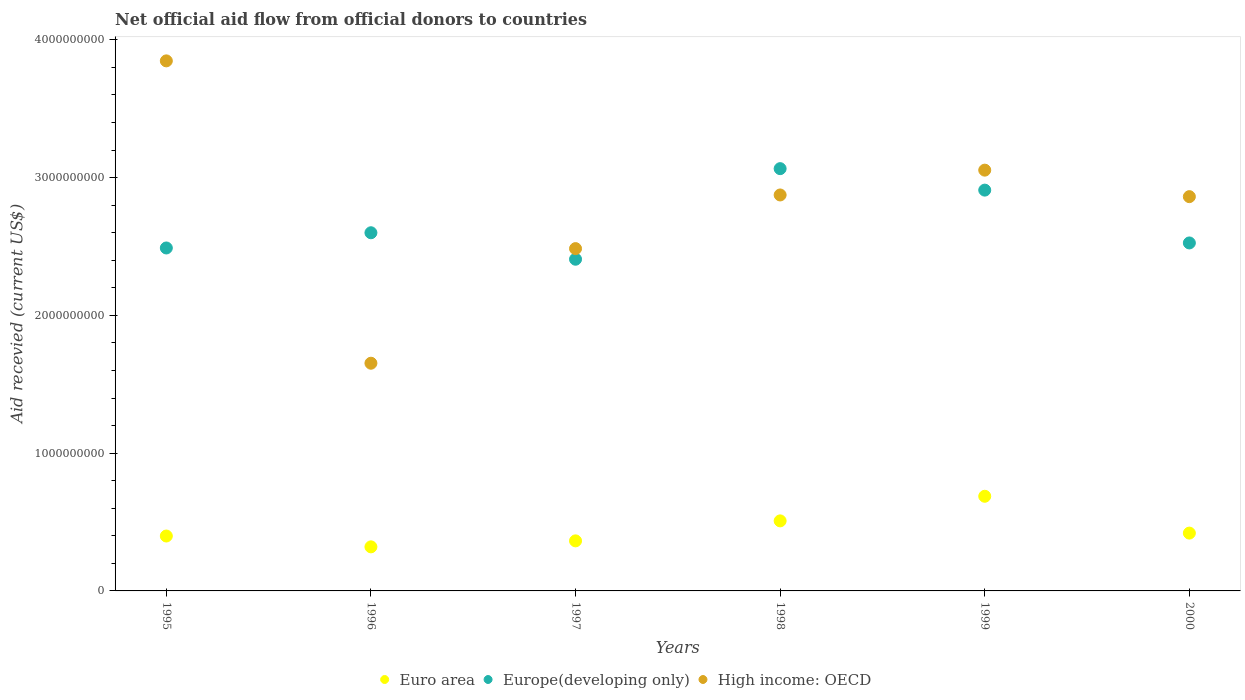How many different coloured dotlines are there?
Your answer should be compact. 3. Is the number of dotlines equal to the number of legend labels?
Ensure brevity in your answer.  Yes. What is the total aid received in Europe(developing only) in 1997?
Give a very brief answer. 2.41e+09. Across all years, what is the maximum total aid received in Euro area?
Provide a succinct answer. 6.87e+08. Across all years, what is the minimum total aid received in Euro area?
Make the answer very short. 3.20e+08. What is the total total aid received in High income: OECD in the graph?
Your answer should be compact. 1.68e+1. What is the difference between the total aid received in Europe(developing only) in 1995 and that in 1997?
Your answer should be compact. 8.17e+07. What is the difference between the total aid received in Euro area in 1995 and the total aid received in Europe(developing only) in 1999?
Provide a short and direct response. -2.51e+09. What is the average total aid received in Europe(developing only) per year?
Offer a terse response. 2.67e+09. In the year 1998, what is the difference between the total aid received in Europe(developing only) and total aid received in Euro area?
Provide a succinct answer. 2.56e+09. In how many years, is the total aid received in Euro area greater than 1800000000 US$?
Offer a very short reply. 0. What is the ratio of the total aid received in Euro area in 1995 to that in 2000?
Make the answer very short. 0.95. What is the difference between the highest and the second highest total aid received in Europe(developing only)?
Make the answer very short. 1.56e+08. What is the difference between the highest and the lowest total aid received in Europe(developing only)?
Your answer should be very brief. 6.57e+08. In how many years, is the total aid received in Europe(developing only) greater than the average total aid received in Europe(developing only) taken over all years?
Offer a terse response. 2. Is the sum of the total aid received in Euro area in 1995 and 1996 greater than the maximum total aid received in High income: OECD across all years?
Your answer should be compact. No. Is it the case that in every year, the sum of the total aid received in Europe(developing only) and total aid received in Euro area  is greater than the total aid received in High income: OECD?
Your answer should be very brief. No. Does the total aid received in Euro area monotonically increase over the years?
Keep it short and to the point. No. Are the values on the major ticks of Y-axis written in scientific E-notation?
Make the answer very short. No. How are the legend labels stacked?
Your answer should be very brief. Horizontal. What is the title of the graph?
Offer a very short reply. Net official aid flow from official donors to countries. What is the label or title of the X-axis?
Provide a short and direct response. Years. What is the label or title of the Y-axis?
Make the answer very short. Aid recevied (current US$). What is the Aid recevied (current US$) in Euro area in 1995?
Your answer should be compact. 3.98e+08. What is the Aid recevied (current US$) of Europe(developing only) in 1995?
Provide a succinct answer. 2.49e+09. What is the Aid recevied (current US$) in High income: OECD in 1995?
Your answer should be compact. 3.85e+09. What is the Aid recevied (current US$) in Euro area in 1996?
Give a very brief answer. 3.20e+08. What is the Aid recevied (current US$) of Europe(developing only) in 1996?
Your answer should be compact. 2.60e+09. What is the Aid recevied (current US$) of High income: OECD in 1996?
Ensure brevity in your answer.  1.65e+09. What is the Aid recevied (current US$) of Euro area in 1997?
Offer a very short reply. 3.63e+08. What is the Aid recevied (current US$) of Europe(developing only) in 1997?
Make the answer very short. 2.41e+09. What is the Aid recevied (current US$) of High income: OECD in 1997?
Provide a short and direct response. 2.48e+09. What is the Aid recevied (current US$) of Euro area in 1998?
Keep it short and to the point. 5.08e+08. What is the Aid recevied (current US$) in Europe(developing only) in 1998?
Offer a terse response. 3.06e+09. What is the Aid recevied (current US$) in High income: OECD in 1998?
Your response must be concise. 2.87e+09. What is the Aid recevied (current US$) in Euro area in 1999?
Ensure brevity in your answer.  6.87e+08. What is the Aid recevied (current US$) in Europe(developing only) in 1999?
Make the answer very short. 2.91e+09. What is the Aid recevied (current US$) in High income: OECD in 1999?
Provide a short and direct response. 3.05e+09. What is the Aid recevied (current US$) of Euro area in 2000?
Keep it short and to the point. 4.20e+08. What is the Aid recevied (current US$) in Europe(developing only) in 2000?
Offer a terse response. 2.53e+09. What is the Aid recevied (current US$) in High income: OECD in 2000?
Ensure brevity in your answer.  2.86e+09. Across all years, what is the maximum Aid recevied (current US$) of Euro area?
Offer a very short reply. 6.87e+08. Across all years, what is the maximum Aid recevied (current US$) in Europe(developing only)?
Provide a succinct answer. 3.06e+09. Across all years, what is the maximum Aid recevied (current US$) in High income: OECD?
Your answer should be compact. 3.85e+09. Across all years, what is the minimum Aid recevied (current US$) of Euro area?
Ensure brevity in your answer.  3.20e+08. Across all years, what is the minimum Aid recevied (current US$) of Europe(developing only)?
Your answer should be compact. 2.41e+09. Across all years, what is the minimum Aid recevied (current US$) in High income: OECD?
Make the answer very short. 1.65e+09. What is the total Aid recevied (current US$) of Euro area in the graph?
Offer a very short reply. 2.70e+09. What is the total Aid recevied (current US$) in Europe(developing only) in the graph?
Give a very brief answer. 1.60e+1. What is the total Aid recevied (current US$) in High income: OECD in the graph?
Provide a short and direct response. 1.68e+1. What is the difference between the Aid recevied (current US$) in Euro area in 1995 and that in 1996?
Your response must be concise. 7.86e+07. What is the difference between the Aid recevied (current US$) in Europe(developing only) in 1995 and that in 1996?
Provide a succinct answer. -1.10e+08. What is the difference between the Aid recevied (current US$) in High income: OECD in 1995 and that in 1996?
Make the answer very short. 2.19e+09. What is the difference between the Aid recevied (current US$) of Euro area in 1995 and that in 1997?
Ensure brevity in your answer.  3.52e+07. What is the difference between the Aid recevied (current US$) in Europe(developing only) in 1995 and that in 1997?
Provide a short and direct response. 8.17e+07. What is the difference between the Aid recevied (current US$) of High income: OECD in 1995 and that in 1997?
Keep it short and to the point. 1.36e+09. What is the difference between the Aid recevied (current US$) of Euro area in 1995 and that in 1998?
Ensure brevity in your answer.  -1.10e+08. What is the difference between the Aid recevied (current US$) in Europe(developing only) in 1995 and that in 1998?
Your answer should be very brief. -5.76e+08. What is the difference between the Aid recevied (current US$) of High income: OECD in 1995 and that in 1998?
Ensure brevity in your answer.  9.73e+08. What is the difference between the Aid recevied (current US$) of Euro area in 1995 and that in 1999?
Ensure brevity in your answer.  -2.88e+08. What is the difference between the Aid recevied (current US$) in Europe(developing only) in 1995 and that in 1999?
Give a very brief answer. -4.20e+08. What is the difference between the Aid recevied (current US$) in High income: OECD in 1995 and that in 1999?
Your response must be concise. 7.93e+08. What is the difference between the Aid recevied (current US$) in Euro area in 1995 and that in 2000?
Give a very brief answer. -2.11e+07. What is the difference between the Aid recevied (current US$) of Europe(developing only) in 1995 and that in 2000?
Your answer should be compact. -3.65e+07. What is the difference between the Aid recevied (current US$) of High income: OECD in 1995 and that in 2000?
Your response must be concise. 9.85e+08. What is the difference between the Aid recevied (current US$) of Euro area in 1996 and that in 1997?
Offer a very short reply. -4.35e+07. What is the difference between the Aid recevied (current US$) in Europe(developing only) in 1996 and that in 1997?
Your answer should be compact. 1.92e+08. What is the difference between the Aid recevied (current US$) of High income: OECD in 1996 and that in 1997?
Your response must be concise. -8.32e+08. What is the difference between the Aid recevied (current US$) in Euro area in 1996 and that in 1998?
Your answer should be compact. -1.88e+08. What is the difference between the Aid recevied (current US$) in Europe(developing only) in 1996 and that in 1998?
Make the answer very short. -4.65e+08. What is the difference between the Aid recevied (current US$) in High income: OECD in 1996 and that in 1998?
Your answer should be compact. -1.22e+09. What is the difference between the Aid recevied (current US$) of Euro area in 1996 and that in 1999?
Offer a terse response. -3.67e+08. What is the difference between the Aid recevied (current US$) in Europe(developing only) in 1996 and that in 1999?
Make the answer very short. -3.09e+08. What is the difference between the Aid recevied (current US$) in High income: OECD in 1996 and that in 1999?
Provide a succinct answer. -1.40e+09. What is the difference between the Aid recevied (current US$) in Euro area in 1996 and that in 2000?
Ensure brevity in your answer.  -9.98e+07. What is the difference between the Aid recevied (current US$) of Europe(developing only) in 1996 and that in 2000?
Make the answer very short. 7.39e+07. What is the difference between the Aid recevied (current US$) of High income: OECD in 1996 and that in 2000?
Ensure brevity in your answer.  -1.21e+09. What is the difference between the Aid recevied (current US$) in Euro area in 1997 and that in 1998?
Ensure brevity in your answer.  -1.45e+08. What is the difference between the Aid recevied (current US$) of Europe(developing only) in 1997 and that in 1998?
Make the answer very short. -6.57e+08. What is the difference between the Aid recevied (current US$) of High income: OECD in 1997 and that in 1998?
Provide a short and direct response. -3.89e+08. What is the difference between the Aid recevied (current US$) in Euro area in 1997 and that in 1999?
Ensure brevity in your answer.  -3.24e+08. What is the difference between the Aid recevied (current US$) of Europe(developing only) in 1997 and that in 1999?
Your answer should be compact. -5.02e+08. What is the difference between the Aid recevied (current US$) of High income: OECD in 1997 and that in 1999?
Provide a succinct answer. -5.70e+08. What is the difference between the Aid recevied (current US$) in Euro area in 1997 and that in 2000?
Your answer should be compact. -5.63e+07. What is the difference between the Aid recevied (current US$) of Europe(developing only) in 1997 and that in 2000?
Your response must be concise. -1.18e+08. What is the difference between the Aid recevied (current US$) of High income: OECD in 1997 and that in 2000?
Offer a terse response. -3.77e+08. What is the difference between the Aid recevied (current US$) in Euro area in 1998 and that in 1999?
Offer a terse response. -1.79e+08. What is the difference between the Aid recevied (current US$) in Europe(developing only) in 1998 and that in 1999?
Ensure brevity in your answer.  1.56e+08. What is the difference between the Aid recevied (current US$) of High income: OECD in 1998 and that in 1999?
Your answer should be compact. -1.80e+08. What is the difference between the Aid recevied (current US$) in Euro area in 1998 and that in 2000?
Give a very brief answer. 8.87e+07. What is the difference between the Aid recevied (current US$) of Europe(developing only) in 1998 and that in 2000?
Offer a very short reply. 5.39e+08. What is the difference between the Aid recevied (current US$) of High income: OECD in 1998 and that in 2000?
Provide a succinct answer. 1.22e+07. What is the difference between the Aid recevied (current US$) in Euro area in 1999 and that in 2000?
Your response must be concise. 2.67e+08. What is the difference between the Aid recevied (current US$) of Europe(developing only) in 1999 and that in 2000?
Your answer should be very brief. 3.83e+08. What is the difference between the Aid recevied (current US$) of High income: OECD in 1999 and that in 2000?
Your answer should be compact. 1.92e+08. What is the difference between the Aid recevied (current US$) of Euro area in 1995 and the Aid recevied (current US$) of Europe(developing only) in 1996?
Your response must be concise. -2.20e+09. What is the difference between the Aid recevied (current US$) of Euro area in 1995 and the Aid recevied (current US$) of High income: OECD in 1996?
Ensure brevity in your answer.  -1.25e+09. What is the difference between the Aid recevied (current US$) in Europe(developing only) in 1995 and the Aid recevied (current US$) in High income: OECD in 1996?
Make the answer very short. 8.36e+08. What is the difference between the Aid recevied (current US$) in Euro area in 1995 and the Aid recevied (current US$) in Europe(developing only) in 1997?
Provide a succinct answer. -2.01e+09. What is the difference between the Aid recevied (current US$) in Euro area in 1995 and the Aid recevied (current US$) in High income: OECD in 1997?
Keep it short and to the point. -2.09e+09. What is the difference between the Aid recevied (current US$) of Europe(developing only) in 1995 and the Aid recevied (current US$) of High income: OECD in 1997?
Give a very brief answer. 4.62e+06. What is the difference between the Aid recevied (current US$) in Euro area in 1995 and the Aid recevied (current US$) in Europe(developing only) in 1998?
Your answer should be very brief. -2.67e+09. What is the difference between the Aid recevied (current US$) in Euro area in 1995 and the Aid recevied (current US$) in High income: OECD in 1998?
Keep it short and to the point. -2.48e+09. What is the difference between the Aid recevied (current US$) of Europe(developing only) in 1995 and the Aid recevied (current US$) of High income: OECD in 1998?
Offer a terse response. -3.85e+08. What is the difference between the Aid recevied (current US$) in Euro area in 1995 and the Aid recevied (current US$) in Europe(developing only) in 1999?
Offer a terse response. -2.51e+09. What is the difference between the Aid recevied (current US$) of Euro area in 1995 and the Aid recevied (current US$) of High income: OECD in 1999?
Ensure brevity in your answer.  -2.66e+09. What is the difference between the Aid recevied (current US$) in Europe(developing only) in 1995 and the Aid recevied (current US$) in High income: OECD in 1999?
Provide a short and direct response. -5.65e+08. What is the difference between the Aid recevied (current US$) in Euro area in 1995 and the Aid recevied (current US$) in Europe(developing only) in 2000?
Provide a short and direct response. -2.13e+09. What is the difference between the Aid recevied (current US$) in Euro area in 1995 and the Aid recevied (current US$) in High income: OECD in 2000?
Your answer should be compact. -2.46e+09. What is the difference between the Aid recevied (current US$) of Europe(developing only) in 1995 and the Aid recevied (current US$) of High income: OECD in 2000?
Keep it short and to the point. -3.73e+08. What is the difference between the Aid recevied (current US$) of Euro area in 1996 and the Aid recevied (current US$) of Europe(developing only) in 1997?
Your answer should be very brief. -2.09e+09. What is the difference between the Aid recevied (current US$) in Euro area in 1996 and the Aid recevied (current US$) in High income: OECD in 1997?
Your response must be concise. -2.16e+09. What is the difference between the Aid recevied (current US$) in Europe(developing only) in 1996 and the Aid recevied (current US$) in High income: OECD in 1997?
Your response must be concise. 1.15e+08. What is the difference between the Aid recevied (current US$) of Euro area in 1996 and the Aid recevied (current US$) of Europe(developing only) in 1998?
Your answer should be very brief. -2.74e+09. What is the difference between the Aid recevied (current US$) in Euro area in 1996 and the Aid recevied (current US$) in High income: OECD in 1998?
Ensure brevity in your answer.  -2.55e+09. What is the difference between the Aid recevied (current US$) of Europe(developing only) in 1996 and the Aid recevied (current US$) of High income: OECD in 1998?
Keep it short and to the point. -2.74e+08. What is the difference between the Aid recevied (current US$) of Euro area in 1996 and the Aid recevied (current US$) of Europe(developing only) in 1999?
Offer a terse response. -2.59e+09. What is the difference between the Aid recevied (current US$) in Euro area in 1996 and the Aid recevied (current US$) in High income: OECD in 1999?
Your response must be concise. -2.73e+09. What is the difference between the Aid recevied (current US$) in Europe(developing only) in 1996 and the Aid recevied (current US$) in High income: OECD in 1999?
Offer a very short reply. -4.54e+08. What is the difference between the Aid recevied (current US$) of Euro area in 1996 and the Aid recevied (current US$) of Europe(developing only) in 2000?
Make the answer very short. -2.21e+09. What is the difference between the Aid recevied (current US$) in Euro area in 1996 and the Aid recevied (current US$) in High income: OECD in 2000?
Provide a succinct answer. -2.54e+09. What is the difference between the Aid recevied (current US$) in Europe(developing only) in 1996 and the Aid recevied (current US$) in High income: OECD in 2000?
Give a very brief answer. -2.62e+08. What is the difference between the Aid recevied (current US$) in Euro area in 1997 and the Aid recevied (current US$) in Europe(developing only) in 1998?
Keep it short and to the point. -2.70e+09. What is the difference between the Aid recevied (current US$) in Euro area in 1997 and the Aid recevied (current US$) in High income: OECD in 1998?
Make the answer very short. -2.51e+09. What is the difference between the Aid recevied (current US$) in Europe(developing only) in 1997 and the Aid recevied (current US$) in High income: OECD in 1998?
Offer a terse response. -4.66e+08. What is the difference between the Aid recevied (current US$) of Euro area in 1997 and the Aid recevied (current US$) of Europe(developing only) in 1999?
Provide a short and direct response. -2.55e+09. What is the difference between the Aid recevied (current US$) in Euro area in 1997 and the Aid recevied (current US$) in High income: OECD in 1999?
Keep it short and to the point. -2.69e+09. What is the difference between the Aid recevied (current US$) of Europe(developing only) in 1997 and the Aid recevied (current US$) of High income: OECD in 1999?
Keep it short and to the point. -6.47e+08. What is the difference between the Aid recevied (current US$) of Euro area in 1997 and the Aid recevied (current US$) of Europe(developing only) in 2000?
Offer a terse response. -2.16e+09. What is the difference between the Aid recevied (current US$) of Euro area in 1997 and the Aid recevied (current US$) of High income: OECD in 2000?
Offer a very short reply. -2.50e+09. What is the difference between the Aid recevied (current US$) of Europe(developing only) in 1997 and the Aid recevied (current US$) of High income: OECD in 2000?
Ensure brevity in your answer.  -4.54e+08. What is the difference between the Aid recevied (current US$) of Euro area in 1998 and the Aid recevied (current US$) of Europe(developing only) in 1999?
Your answer should be compact. -2.40e+09. What is the difference between the Aid recevied (current US$) in Euro area in 1998 and the Aid recevied (current US$) in High income: OECD in 1999?
Give a very brief answer. -2.55e+09. What is the difference between the Aid recevied (current US$) of Europe(developing only) in 1998 and the Aid recevied (current US$) of High income: OECD in 1999?
Make the answer very short. 1.09e+07. What is the difference between the Aid recevied (current US$) in Euro area in 1998 and the Aid recevied (current US$) in Europe(developing only) in 2000?
Keep it short and to the point. -2.02e+09. What is the difference between the Aid recevied (current US$) of Euro area in 1998 and the Aid recevied (current US$) of High income: OECD in 2000?
Offer a terse response. -2.35e+09. What is the difference between the Aid recevied (current US$) of Europe(developing only) in 1998 and the Aid recevied (current US$) of High income: OECD in 2000?
Offer a very short reply. 2.03e+08. What is the difference between the Aid recevied (current US$) in Euro area in 1999 and the Aid recevied (current US$) in Europe(developing only) in 2000?
Your answer should be compact. -1.84e+09. What is the difference between the Aid recevied (current US$) in Euro area in 1999 and the Aid recevied (current US$) in High income: OECD in 2000?
Provide a short and direct response. -2.17e+09. What is the difference between the Aid recevied (current US$) of Europe(developing only) in 1999 and the Aid recevied (current US$) of High income: OECD in 2000?
Your answer should be compact. 4.73e+07. What is the average Aid recevied (current US$) in Euro area per year?
Offer a terse response. 4.49e+08. What is the average Aid recevied (current US$) of Europe(developing only) per year?
Your response must be concise. 2.67e+09. What is the average Aid recevied (current US$) of High income: OECD per year?
Your response must be concise. 2.80e+09. In the year 1995, what is the difference between the Aid recevied (current US$) of Euro area and Aid recevied (current US$) of Europe(developing only)?
Keep it short and to the point. -2.09e+09. In the year 1995, what is the difference between the Aid recevied (current US$) of Euro area and Aid recevied (current US$) of High income: OECD?
Your answer should be compact. -3.45e+09. In the year 1995, what is the difference between the Aid recevied (current US$) in Europe(developing only) and Aid recevied (current US$) in High income: OECD?
Make the answer very short. -1.36e+09. In the year 1996, what is the difference between the Aid recevied (current US$) in Euro area and Aid recevied (current US$) in Europe(developing only)?
Offer a very short reply. -2.28e+09. In the year 1996, what is the difference between the Aid recevied (current US$) of Euro area and Aid recevied (current US$) of High income: OECD?
Your answer should be very brief. -1.33e+09. In the year 1996, what is the difference between the Aid recevied (current US$) of Europe(developing only) and Aid recevied (current US$) of High income: OECD?
Provide a short and direct response. 9.47e+08. In the year 1997, what is the difference between the Aid recevied (current US$) of Euro area and Aid recevied (current US$) of Europe(developing only)?
Your answer should be compact. -2.04e+09. In the year 1997, what is the difference between the Aid recevied (current US$) in Euro area and Aid recevied (current US$) in High income: OECD?
Ensure brevity in your answer.  -2.12e+09. In the year 1997, what is the difference between the Aid recevied (current US$) of Europe(developing only) and Aid recevied (current US$) of High income: OECD?
Keep it short and to the point. -7.71e+07. In the year 1998, what is the difference between the Aid recevied (current US$) in Euro area and Aid recevied (current US$) in Europe(developing only)?
Provide a short and direct response. -2.56e+09. In the year 1998, what is the difference between the Aid recevied (current US$) of Euro area and Aid recevied (current US$) of High income: OECD?
Your answer should be compact. -2.37e+09. In the year 1998, what is the difference between the Aid recevied (current US$) in Europe(developing only) and Aid recevied (current US$) in High income: OECD?
Offer a very short reply. 1.91e+08. In the year 1999, what is the difference between the Aid recevied (current US$) of Euro area and Aid recevied (current US$) of Europe(developing only)?
Keep it short and to the point. -2.22e+09. In the year 1999, what is the difference between the Aid recevied (current US$) of Euro area and Aid recevied (current US$) of High income: OECD?
Provide a short and direct response. -2.37e+09. In the year 1999, what is the difference between the Aid recevied (current US$) of Europe(developing only) and Aid recevied (current US$) of High income: OECD?
Make the answer very short. -1.45e+08. In the year 2000, what is the difference between the Aid recevied (current US$) of Euro area and Aid recevied (current US$) of Europe(developing only)?
Keep it short and to the point. -2.11e+09. In the year 2000, what is the difference between the Aid recevied (current US$) in Euro area and Aid recevied (current US$) in High income: OECD?
Make the answer very short. -2.44e+09. In the year 2000, what is the difference between the Aid recevied (current US$) of Europe(developing only) and Aid recevied (current US$) of High income: OECD?
Your answer should be very brief. -3.36e+08. What is the ratio of the Aid recevied (current US$) of Euro area in 1995 to that in 1996?
Keep it short and to the point. 1.25. What is the ratio of the Aid recevied (current US$) of Europe(developing only) in 1995 to that in 1996?
Provide a short and direct response. 0.96. What is the ratio of the Aid recevied (current US$) in High income: OECD in 1995 to that in 1996?
Make the answer very short. 2.33. What is the ratio of the Aid recevied (current US$) of Euro area in 1995 to that in 1997?
Keep it short and to the point. 1.1. What is the ratio of the Aid recevied (current US$) in Europe(developing only) in 1995 to that in 1997?
Give a very brief answer. 1.03. What is the ratio of the Aid recevied (current US$) of High income: OECD in 1995 to that in 1997?
Provide a short and direct response. 1.55. What is the ratio of the Aid recevied (current US$) of Euro area in 1995 to that in 1998?
Your answer should be very brief. 0.78. What is the ratio of the Aid recevied (current US$) in Europe(developing only) in 1995 to that in 1998?
Provide a short and direct response. 0.81. What is the ratio of the Aid recevied (current US$) in High income: OECD in 1995 to that in 1998?
Ensure brevity in your answer.  1.34. What is the ratio of the Aid recevied (current US$) in Euro area in 1995 to that in 1999?
Provide a short and direct response. 0.58. What is the ratio of the Aid recevied (current US$) in Europe(developing only) in 1995 to that in 1999?
Ensure brevity in your answer.  0.86. What is the ratio of the Aid recevied (current US$) of High income: OECD in 1995 to that in 1999?
Offer a terse response. 1.26. What is the ratio of the Aid recevied (current US$) in Euro area in 1995 to that in 2000?
Your response must be concise. 0.95. What is the ratio of the Aid recevied (current US$) in Europe(developing only) in 1995 to that in 2000?
Keep it short and to the point. 0.99. What is the ratio of the Aid recevied (current US$) of High income: OECD in 1995 to that in 2000?
Your answer should be very brief. 1.34. What is the ratio of the Aid recevied (current US$) in Euro area in 1996 to that in 1997?
Your response must be concise. 0.88. What is the ratio of the Aid recevied (current US$) in Europe(developing only) in 1996 to that in 1997?
Keep it short and to the point. 1.08. What is the ratio of the Aid recevied (current US$) of High income: OECD in 1996 to that in 1997?
Provide a succinct answer. 0.67. What is the ratio of the Aid recevied (current US$) in Euro area in 1996 to that in 1998?
Your answer should be compact. 0.63. What is the ratio of the Aid recevied (current US$) of Europe(developing only) in 1996 to that in 1998?
Your response must be concise. 0.85. What is the ratio of the Aid recevied (current US$) in High income: OECD in 1996 to that in 1998?
Your answer should be compact. 0.58. What is the ratio of the Aid recevied (current US$) in Euro area in 1996 to that in 1999?
Your answer should be very brief. 0.47. What is the ratio of the Aid recevied (current US$) of Europe(developing only) in 1996 to that in 1999?
Your answer should be very brief. 0.89. What is the ratio of the Aid recevied (current US$) in High income: OECD in 1996 to that in 1999?
Offer a terse response. 0.54. What is the ratio of the Aid recevied (current US$) in Euro area in 1996 to that in 2000?
Make the answer very short. 0.76. What is the ratio of the Aid recevied (current US$) of Europe(developing only) in 1996 to that in 2000?
Offer a very short reply. 1.03. What is the ratio of the Aid recevied (current US$) in High income: OECD in 1996 to that in 2000?
Make the answer very short. 0.58. What is the ratio of the Aid recevied (current US$) of Euro area in 1997 to that in 1998?
Your answer should be very brief. 0.71. What is the ratio of the Aid recevied (current US$) of Europe(developing only) in 1997 to that in 1998?
Provide a succinct answer. 0.79. What is the ratio of the Aid recevied (current US$) of High income: OECD in 1997 to that in 1998?
Provide a short and direct response. 0.86. What is the ratio of the Aid recevied (current US$) in Euro area in 1997 to that in 1999?
Provide a succinct answer. 0.53. What is the ratio of the Aid recevied (current US$) of Europe(developing only) in 1997 to that in 1999?
Provide a succinct answer. 0.83. What is the ratio of the Aid recevied (current US$) of High income: OECD in 1997 to that in 1999?
Give a very brief answer. 0.81. What is the ratio of the Aid recevied (current US$) in Euro area in 1997 to that in 2000?
Provide a short and direct response. 0.87. What is the ratio of the Aid recevied (current US$) of Europe(developing only) in 1997 to that in 2000?
Provide a succinct answer. 0.95. What is the ratio of the Aid recevied (current US$) of High income: OECD in 1997 to that in 2000?
Your answer should be very brief. 0.87. What is the ratio of the Aid recevied (current US$) in Euro area in 1998 to that in 1999?
Provide a succinct answer. 0.74. What is the ratio of the Aid recevied (current US$) of Europe(developing only) in 1998 to that in 1999?
Offer a very short reply. 1.05. What is the ratio of the Aid recevied (current US$) of High income: OECD in 1998 to that in 1999?
Provide a short and direct response. 0.94. What is the ratio of the Aid recevied (current US$) of Euro area in 1998 to that in 2000?
Offer a very short reply. 1.21. What is the ratio of the Aid recevied (current US$) of Europe(developing only) in 1998 to that in 2000?
Give a very brief answer. 1.21. What is the ratio of the Aid recevied (current US$) of High income: OECD in 1998 to that in 2000?
Give a very brief answer. 1. What is the ratio of the Aid recevied (current US$) in Euro area in 1999 to that in 2000?
Offer a very short reply. 1.64. What is the ratio of the Aid recevied (current US$) in Europe(developing only) in 1999 to that in 2000?
Ensure brevity in your answer.  1.15. What is the ratio of the Aid recevied (current US$) in High income: OECD in 1999 to that in 2000?
Your response must be concise. 1.07. What is the difference between the highest and the second highest Aid recevied (current US$) of Euro area?
Your response must be concise. 1.79e+08. What is the difference between the highest and the second highest Aid recevied (current US$) in Europe(developing only)?
Keep it short and to the point. 1.56e+08. What is the difference between the highest and the second highest Aid recevied (current US$) in High income: OECD?
Give a very brief answer. 7.93e+08. What is the difference between the highest and the lowest Aid recevied (current US$) in Euro area?
Your answer should be very brief. 3.67e+08. What is the difference between the highest and the lowest Aid recevied (current US$) in Europe(developing only)?
Give a very brief answer. 6.57e+08. What is the difference between the highest and the lowest Aid recevied (current US$) of High income: OECD?
Offer a terse response. 2.19e+09. 